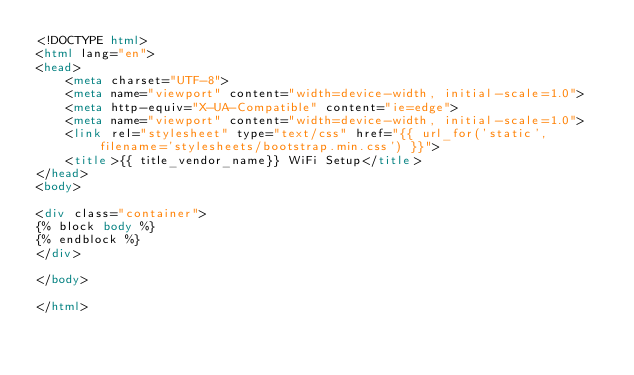<code> <loc_0><loc_0><loc_500><loc_500><_HTML_><!DOCTYPE html>
<html lang="en">
<head>
    <meta charset="UTF-8">
    <meta name="viewport" content="width=device-width, initial-scale=1.0">
    <meta http-equiv="X-UA-Compatible" content="ie=edge">
    <meta name="viewport" content="width=device-width, initial-scale=1.0">
    <link rel="stylesheet" type="text/css" href="{{ url_for('static', filename='stylesheets/bootstrap.min.css') }}">
    <title>{{ title_vendor_name}} WiFi Setup</title>
</head>
<body>

<div class="container">
{% block body %}
{% endblock %}
</div>

</body>

</html>
</code> 